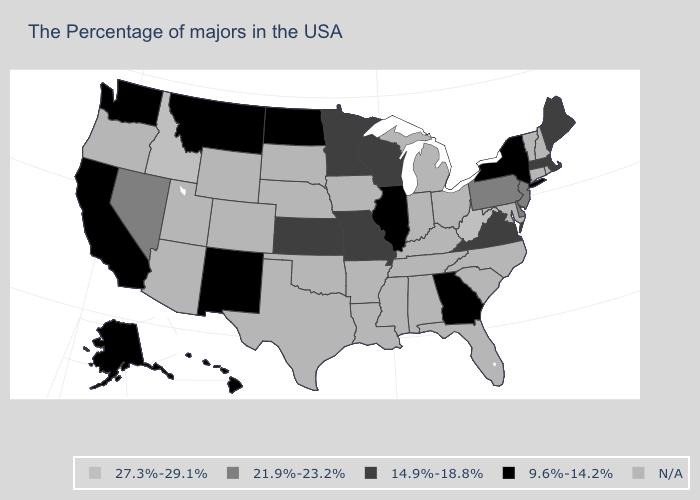What is the value of Oklahoma?
Answer briefly. N/A. What is the highest value in the USA?
Quick response, please. 27.3%-29.1%. Which states have the lowest value in the USA?
Give a very brief answer. New York, Georgia, Illinois, North Dakota, New Mexico, Montana, California, Washington, Alaska, Hawaii. What is the lowest value in states that border Ohio?
Keep it brief. 21.9%-23.2%. Which states have the lowest value in the South?
Keep it brief. Georgia. Does the first symbol in the legend represent the smallest category?
Keep it brief. No. Name the states that have a value in the range N/A?
Write a very short answer. Rhode Island, New Hampshire, Vermont, Connecticut, Maryland, North Carolina, South Carolina, Ohio, Florida, Michigan, Kentucky, Indiana, Alabama, Tennessee, Mississippi, Louisiana, Arkansas, Iowa, Nebraska, Oklahoma, Texas, South Dakota, Wyoming, Colorado, Utah, Arizona, Oregon. Does Georgia have the lowest value in the South?
Give a very brief answer. Yes. Name the states that have a value in the range N/A?
Concise answer only. Rhode Island, New Hampshire, Vermont, Connecticut, Maryland, North Carolina, South Carolina, Ohio, Florida, Michigan, Kentucky, Indiana, Alabama, Tennessee, Mississippi, Louisiana, Arkansas, Iowa, Nebraska, Oklahoma, Texas, South Dakota, Wyoming, Colorado, Utah, Arizona, Oregon. What is the value of Delaware?
Keep it brief. 21.9%-23.2%. What is the value of Connecticut?
Give a very brief answer. N/A. What is the highest value in the MidWest ?
Quick response, please. 14.9%-18.8%. What is the lowest value in the South?
Be succinct. 9.6%-14.2%. Among the states that border South Dakota , which have the lowest value?
Quick response, please. North Dakota, Montana. Which states have the highest value in the USA?
Quick response, please. West Virginia, Idaho. 